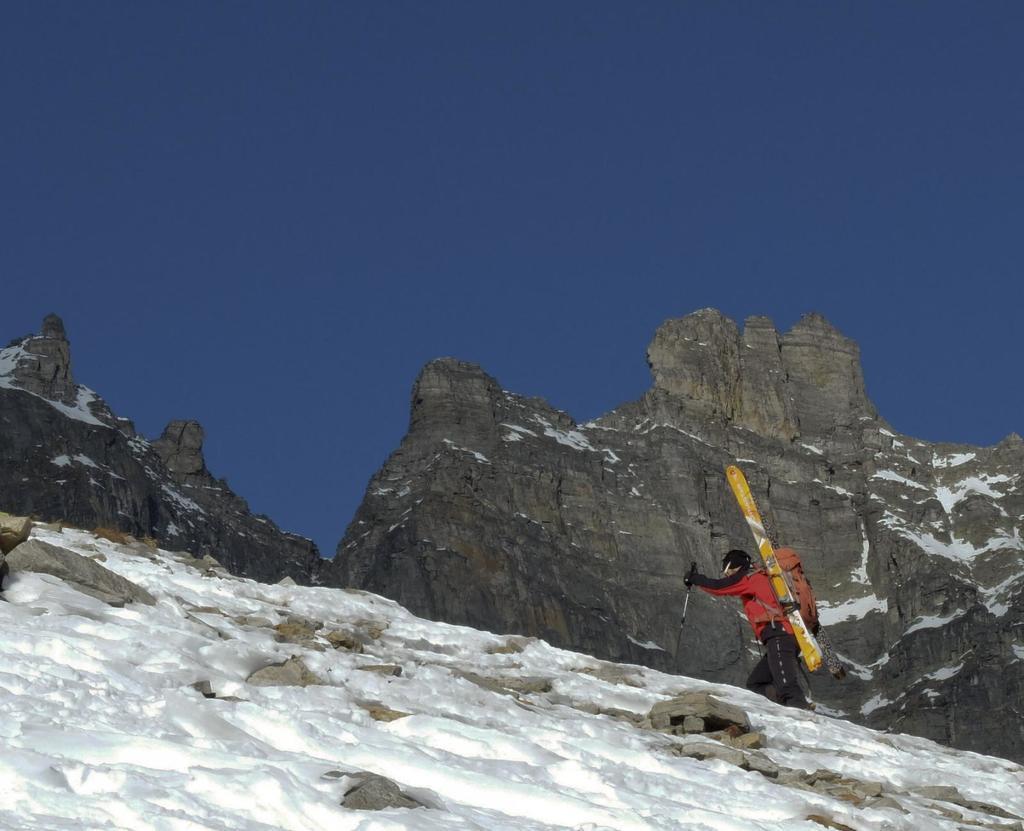Could you give a brief overview of what you see in this image? This picture is clicked outside. In the foreground we can see the rocks and there is a lot of snow. On the right we can see a person wearing backpack and some objects seems to be the ski-boards and holding an object and seems to be walking. In the background we can see the sky and the rocks. 